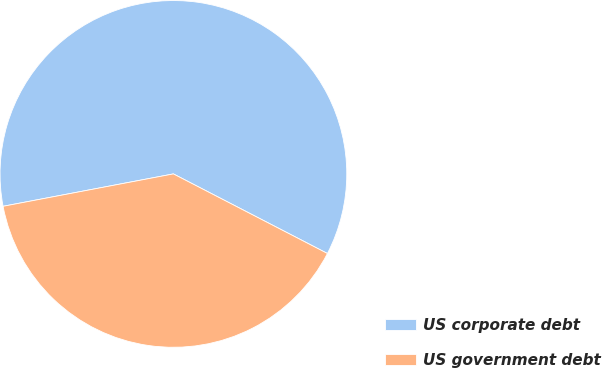Convert chart to OTSL. <chart><loc_0><loc_0><loc_500><loc_500><pie_chart><fcel>US corporate debt<fcel>US government debt<nl><fcel>60.58%<fcel>39.42%<nl></chart> 